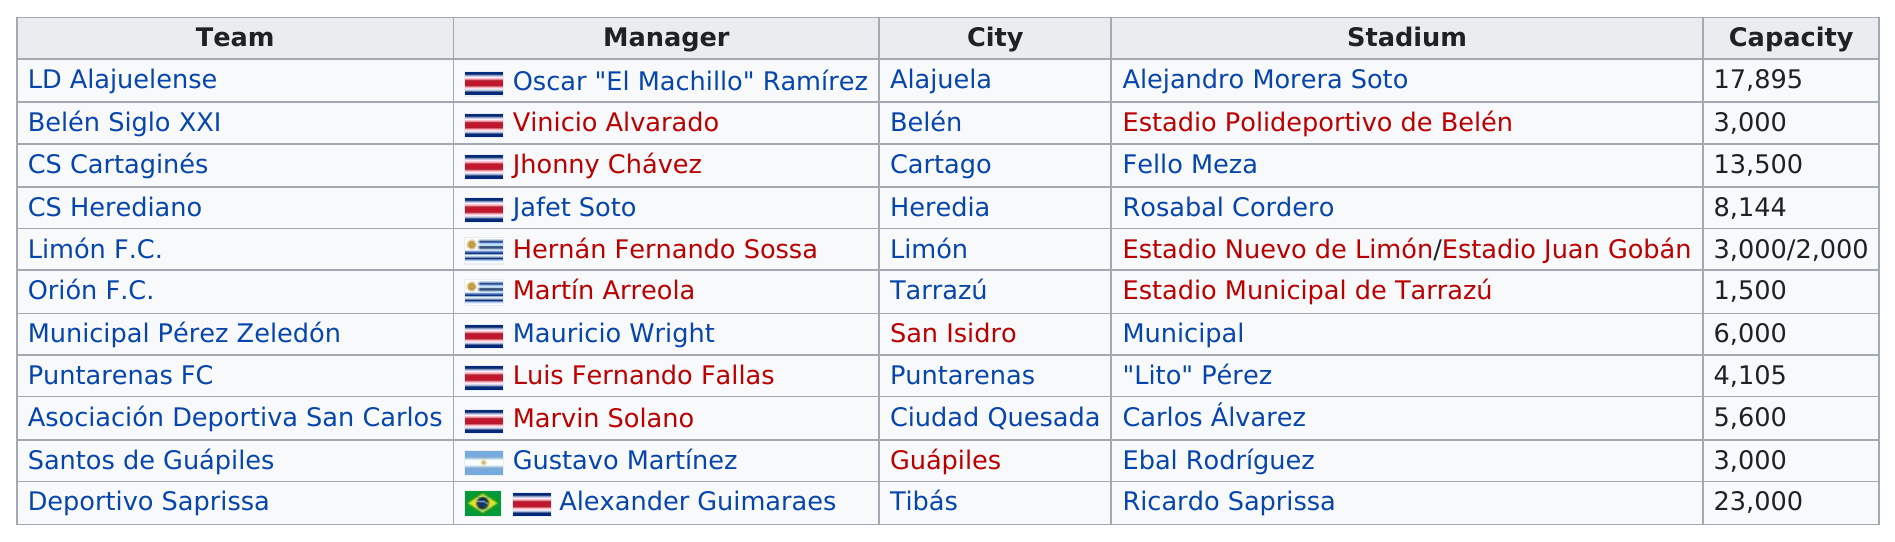Draw attention to some important aspects in this diagram. There are a total of 11 teams participating in this division. The biggest capacity stadium is called Ricardo Saprissa. The combined capacity of Tarrazu and Guapiles stadiums is 4,500. The Alajuela's stadium can seat more people than the Puntarenas' stadium, with a capacity of 13,790, as compared to 10,000. The most amount of people that can attend a Deportivo Saprissa game at Ricardo Saprissa Stadium is 23,000. 